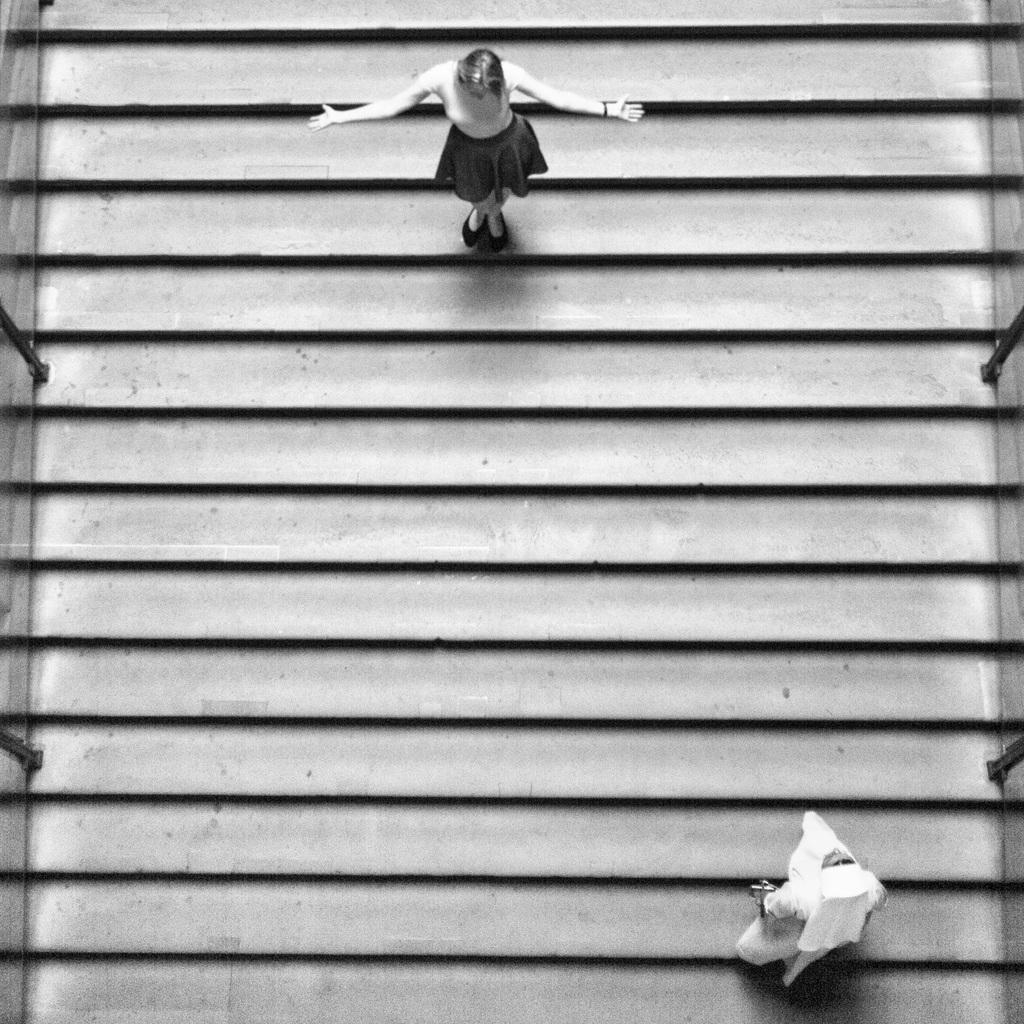Could you give a brief overview of what you see in this image? As we can see in the image there are stairs and two persons. The woman on the right side bottom is wearing white color dress. 